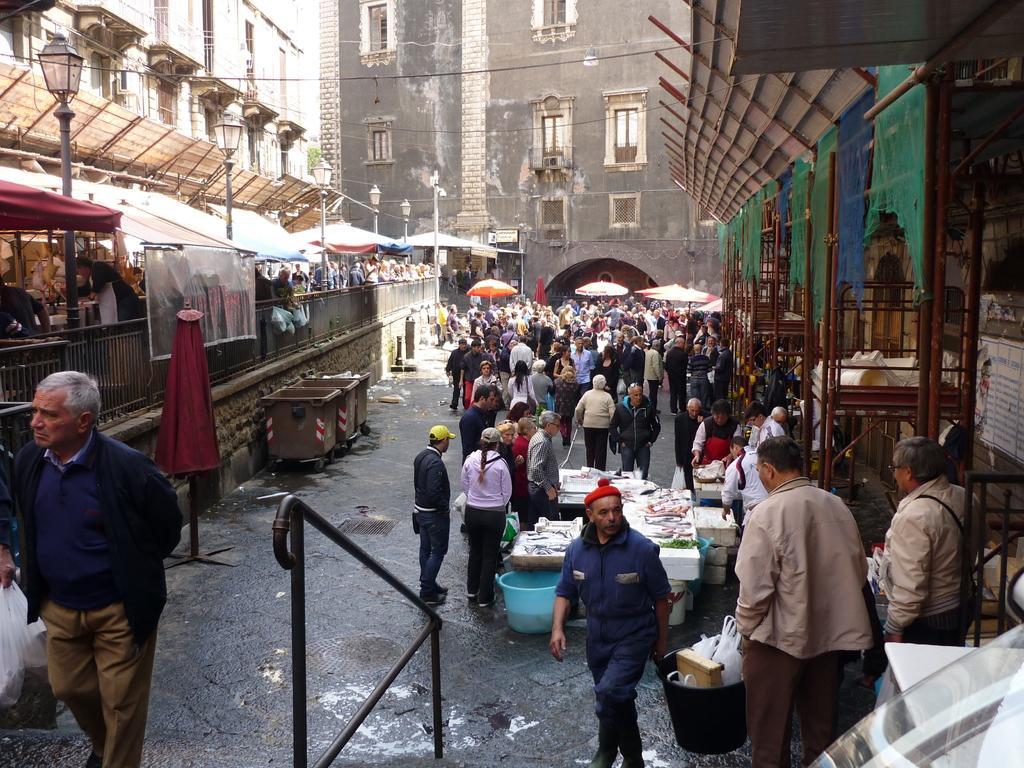Please provide a concise description of this image. In this picture I can observe some people walking on the road. On the left side there is a railing. I can observe buildings in the background. On the either sides of the road I can observe some stalls. 